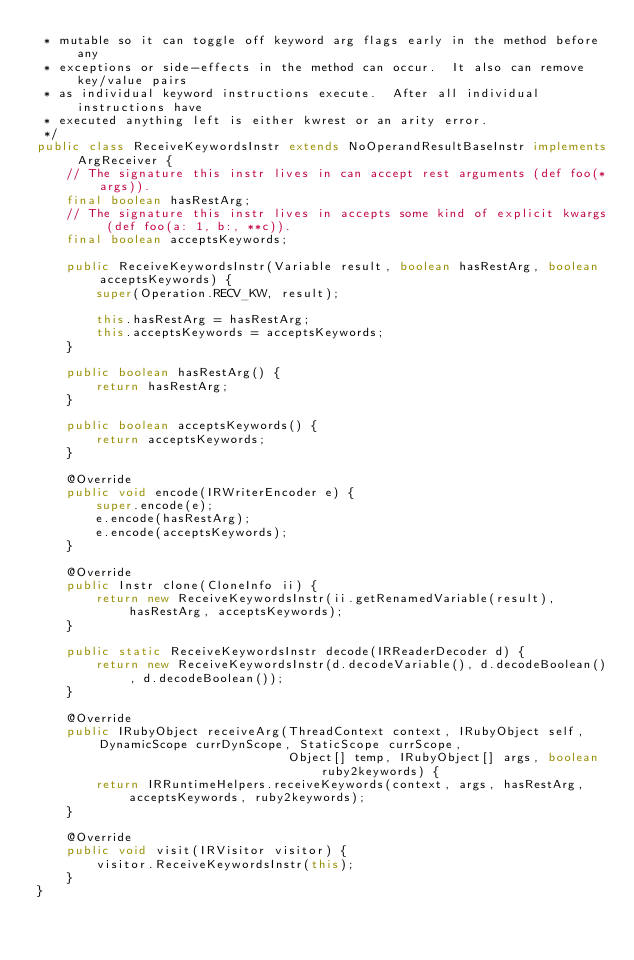Convert code to text. <code><loc_0><loc_0><loc_500><loc_500><_Java_> * mutable so it can toggle off keyword arg flags early in the method before any
 * exceptions or side-effects in the method can occur.  It also can remove key/value pairs
 * as individual keyword instructions execute.  After all individual instructions have
 * executed anything left is either kwrest or an arity error.
 */
public class ReceiveKeywordsInstr extends NoOperandResultBaseInstr implements ArgReceiver {
    // The signature this instr lives in can accept rest arguments (def foo(*args)).
    final boolean hasRestArg;
    // The signature this instr lives in accepts some kind of explicit kwargs (def foo(a: 1, b:, **c)).
    final boolean acceptsKeywords;

    public ReceiveKeywordsInstr(Variable result, boolean hasRestArg, boolean acceptsKeywords) {
        super(Operation.RECV_KW, result);

        this.hasRestArg = hasRestArg;
        this.acceptsKeywords = acceptsKeywords;
    }

    public boolean hasRestArg() {
        return hasRestArg;
    }

    public boolean acceptsKeywords() {
        return acceptsKeywords;
    }

    @Override
    public void encode(IRWriterEncoder e) {
        super.encode(e);
        e.encode(hasRestArg);
        e.encode(acceptsKeywords);
    }    

    @Override
    public Instr clone(CloneInfo ii) {
        return new ReceiveKeywordsInstr(ii.getRenamedVariable(result), hasRestArg, acceptsKeywords);
    }

    public static ReceiveKeywordsInstr decode(IRReaderDecoder d) {
        return new ReceiveKeywordsInstr(d.decodeVariable(), d.decodeBoolean(), d.decodeBoolean());
    }

    @Override
    public IRubyObject receiveArg(ThreadContext context, IRubyObject self, DynamicScope currDynScope, StaticScope currScope,
                                  Object[] temp, IRubyObject[] args, boolean ruby2keywords) {
        return IRRuntimeHelpers.receiveKeywords(context, args, hasRestArg, acceptsKeywords, ruby2keywords);
    }

    @Override
    public void visit(IRVisitor visitor) {
        visitor.ReceiveKeywordsInstr(this);
    }
}
</code> 